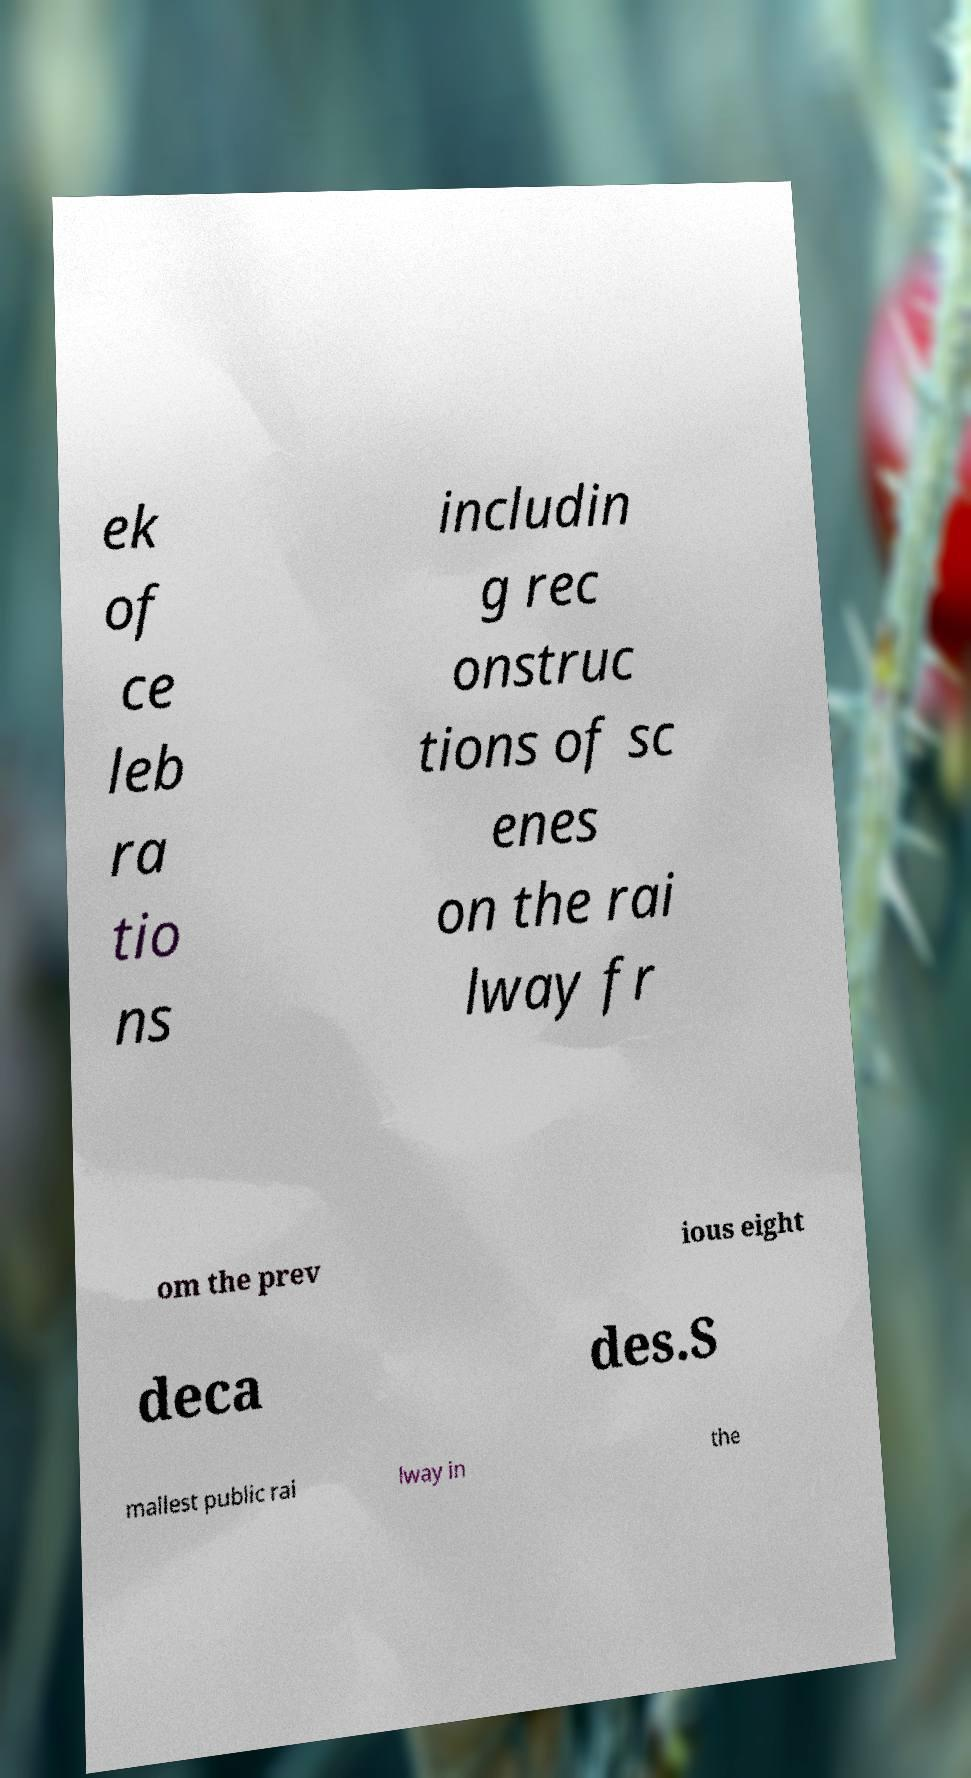Please identify and transcribe the text found in this image. ek of ce leb ra tio ns includin g rec onstruc tions of sc enes on the rai lway fr om the prev ious eight deca des.S mallest public rai lway in the 